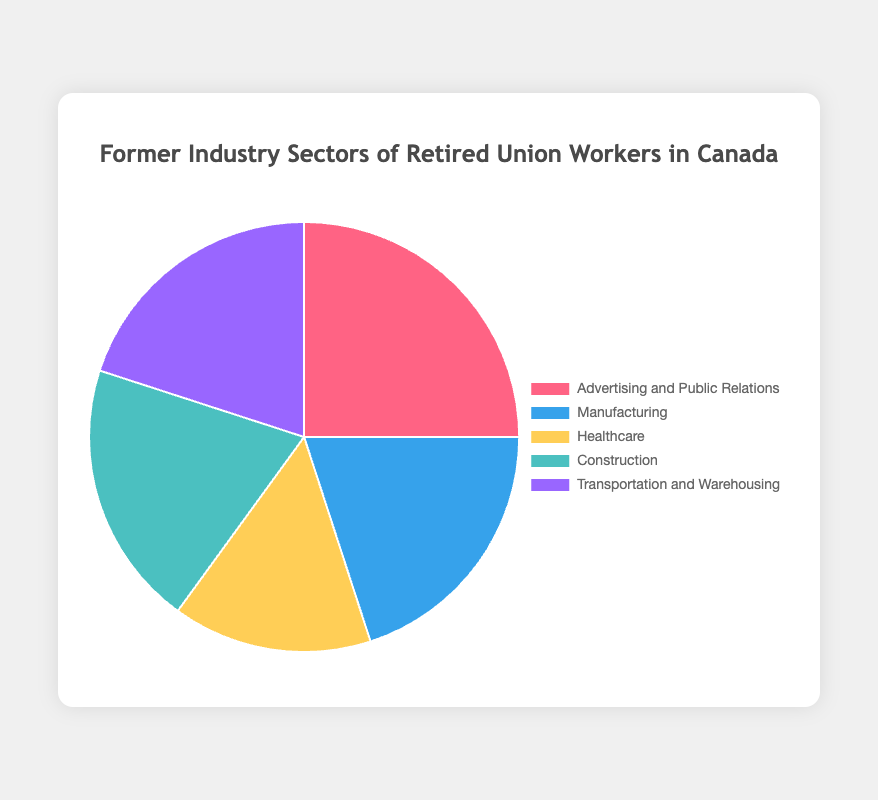What percentage of retired union workers were from the Manufacturing sector? The Manufacturing sector makes up 20% of the retired union workers, as shown in the pie chart.
Answer: 20% Which sector has the highest percentage of retired union workers? The pie chart shows that the Advertising and Public Relations sector has the highest percentage at 25%.
Answer: Advertising and Public Relations Are there any sectors with an equal percentage of retired union workers? If so, which ones? Yes, the Manufacturing, Construction, and Transportation and Warehousing sectors each have 20% of retired union workers.
Answer: Manufacturing, Construction, Transportation and Warehousing What is the combined percentage of retired union workers from the Construction and Transportation and Warehousing sectors? The percentage of retired union workers from the Construction sector is 20%, and from the Transportation and Warehousing sector is also 20%. Combined, this is 20% + 20% = 40%.
Answer: 40% By how much does the percentage of retired union workers from the Advertising and Public Relations sector exceed that from the Healthcare sector? The percentage from Advertising and Public Relations is 25%, and from Healthcare is 15%. The difference is 25% - 15% = 10%.
Answer: 10% What is the average percentage of retired union workers across all sectors? To find the average, sum up the percentages of all sectors: 25% (Advertising and Public Relations) + 20% (Manufacturing) + 15% (Healthcare) + 20% (Construction) + 20% (Transportation and Warehousing) = 100%. Divide by the number of sectors (5): 100% / 5 = 20%.
Answer: 20% Which sector is represented by the yellow color in the pie chart, and what percentage does it represent? The yellow color represents the Healthcare sector, which accounts for 15% of the retired union workers.
Answer: Healthcare, 15% 